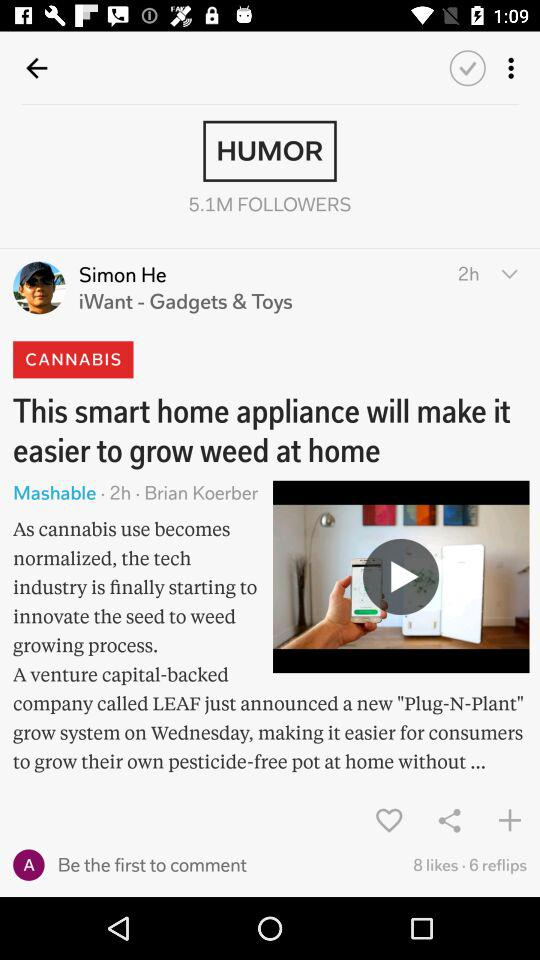How many more likes does the post have than reflips?
Answer the question using a single word or phrase. 2 